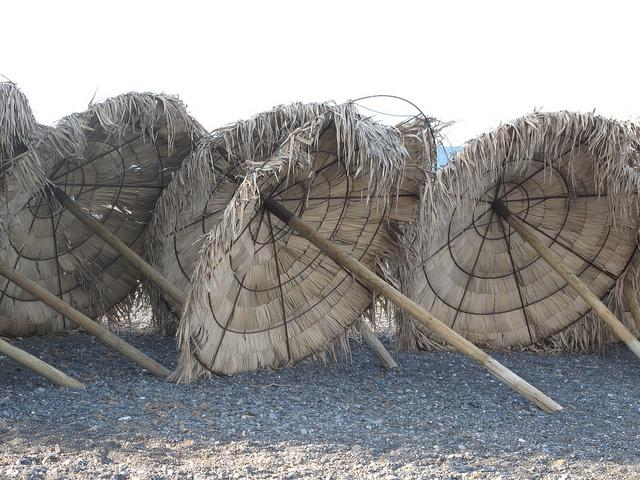What style of umbrella is seen here? Please explain your reasoning. thatched. The umbrellas are covered in a straw type covering. 